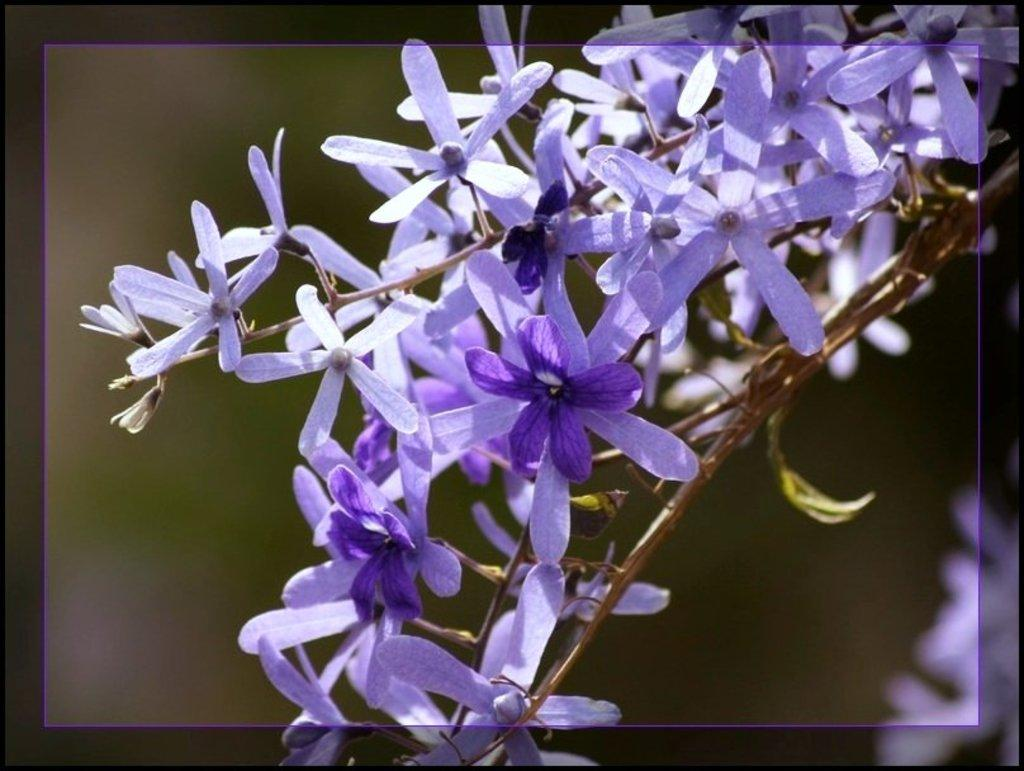What type of flowers are present in the image? There are lavender flowers in the image. What color are the lavender flowers? The lavender flowers are in purple color. What type of shoes can be seen with the lavender flowers in the image? There are no shoes present in the image; it only features lavender flowers. How many seeds can be counted in the lavender flowers in the image? The image does not show individual seeds of the lavender flowers, so it is not possible to count them. 